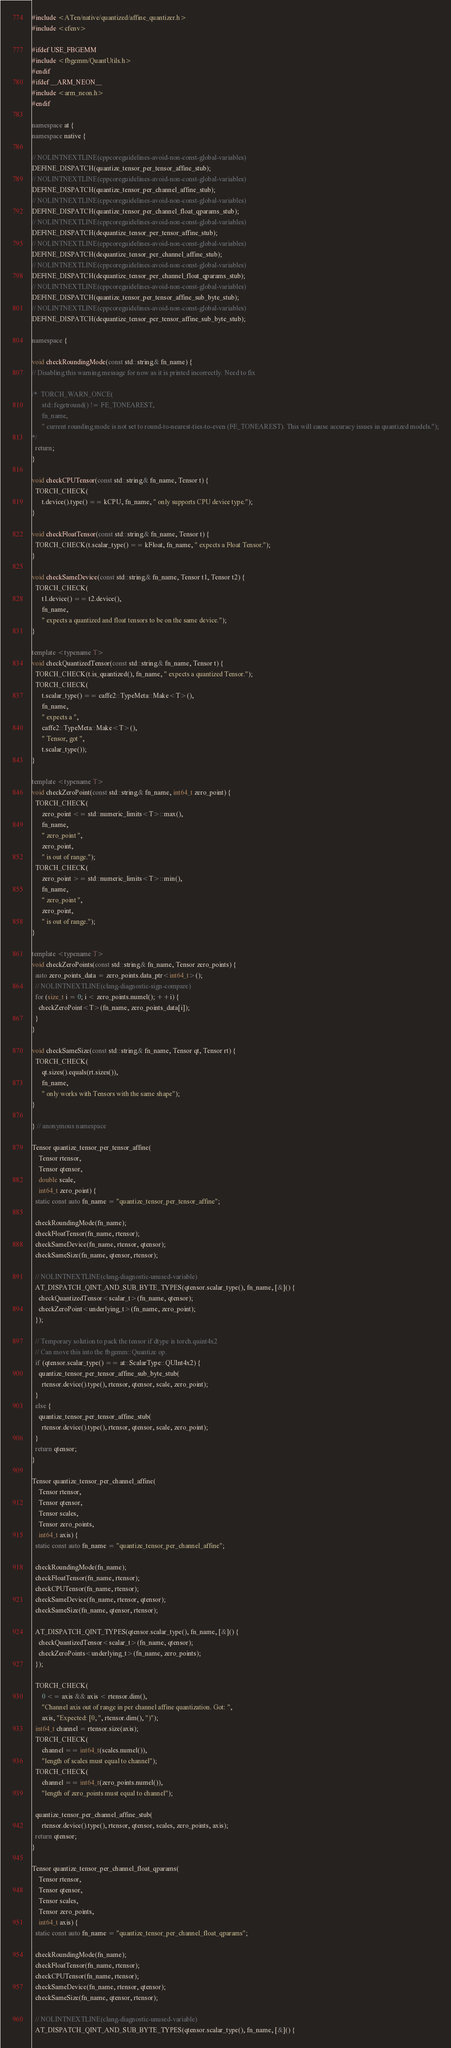<code> <loc_0><loc_0><loc_500><loc_500><_C++_>#include <ATen/native/quantized/affine_quantizer.h>
#include <cfenv>

#ifdef USE_FBGEMM
#include <fbgemm/QuantUtils.h>
#endif
#ifdef __ARM_NEON__
#include <arm_neon.h>
#endif

namespace at {
namespace native {

// NOLINTNEXTLINE(cppcoreguidelines-avoid-non-const-global-variables)
DEFINE_DISPATCH(quantize_tensor_per_tensor_affine_stub);
// NOLINTNEXTLINE(cppcoreguidelines-avoid-non-const-global-variables)
DEFINE_DISPATCH(quantize_tensor_per_channel_affine_stub);
// NOLINTNEXTLINE(cppcoreguidelines-avoid-non-const-global-variables)
DEFINE_DISPATCH(quantize_tensor_per_channel_float_qparams_stub);
// NOLINTNEXTLINE(cppcoreguidelines-avoid-non-const-global-variables)
DEFINE_DISPATCH(dequantize_tensor_per_tensor_affine_stub);
// NOLINTNEXTLINE(cppcoreguidelines-avoid-non-const-global-variables)
DEFINE_DISPATCH(dequantize_tensor_per_channel_affine_stub);
// NOLINTNEXTLINE(cppcoreguidelines-avoid-non-const-global-variables)
DEFINE_DISPATCH(dequantize_tensor_per_channel_float_qparams_stub);
// NOLINTNEXTLINE(cppcoreguidelines-avoid-non-const-global-variables)
DEFINE_DISPATCH(quantize_tensor_per_tensor_affine_sub_byte_stub);
// NOLINTNEXTLINE(cppcoreguidelines-avoid-non-const-global-variables)
DEFINE_DISPATCH(dequantize_tensor_per_tensor_affine_sub_byte_stub);

namespace {

void checkRoundingMode(const std::string& fn_name) {
// Disabling this warning message for now as it is printed incorrectly. Need to fix

/*  TORCH_WARN_ONCE(
      std::fegetround() != FE_TONEAREST,
      fn_name,
      " current rounding mode is not set to round-to-nearest-ties-to-even (FE_TONEAREST). This will cause accuracy issues in quantized models.");
*/
  return;
}

void checkCPUTensor(const std::string& fn_name, Tensor t) {
  TORCH_CHECK(
      t.device().type() == kCPU, fn_name, " only supports CPU device type.");
}

void checkFloatTensor(const std::string& fn_name, Tensor t) {
  TORCH_CHECK(t.scalar_type() == kFloat, fn_name, " expects a Float Tensor.");
}

void checkSameDevice(const std::string& fn_name, Tensor t1, Tensor t2) {
  TORCH_CHECK(
      t1.device() == t2.device(),
      fn_name,
      " expects a quantized and float tensors to be on the same device.");
}

template <typename T>
void checkQuantizedTensor(const std::string& fn_name, Tensor t) {
  TORCH_CHECK(t.is_quantized(), fn_name, " expects a quantized Tensor.");
  TORCH_CHECK(
      t.scalar_type() == caffe2::TypeMeta::Make<T>(),
      fn_name,
      " expects a ",
      caffe2::TypeMeta::Make<T>(),
      " Tensor, got ",
      t.scalar_type());
}

template <typename T>
void checkZeroPoint(const std::string& fn_name, int64_t zero_point) {
  TORCH_CHECK(
      zero_point <= std::numeric_limits<T>::max(),
      fn_name,
      " zero_point ",
      zero_point,
      " is out of range.");
  TORCH_CHECK(
      zero_point >= std::numeric_limits<T>::min(),
      fn_name,
      " zero_point ",
      zero_point,
      " is out of range.");
}

template <typename T>
void checkZeroPoints(const std::string& fn_name, Tensor zero_points) {
  auto zero_points_data = zero_points.data_ptr<int64_t>();
  // NOLINTNEXTLINE(clang-diagnostic-sign-compare)
  for (size_t i = 0; i < zero_points.numel(); ++i) {
    checkZeroPoint<T>(fn_name, zero_points_data[i]);
  }
}

void checkSameSize(const std::string& fn_name, Tensor qt, Tensor rt) {
  TORCH_CHECK(
      qt.sizes().equals(rt.sizes()),
      fn_name,
      " only works with Tensors with the same shape");
}

} // anonymous namespace

Tensor quantize_tensor_per_tensor_affine(
    Tensor rtensor,
    Tensor qtensor,
    double scale,
    int64_t zero_point) {
  static const auto fn_name = "quantize_tensor_per_tensor_affine";

  checkRoundingMode(fn_name);
  checkFloatTensor(fn_name, rtensor);
  checkSameDevice(fn_name, rtensor, qtensor);
  checkSameSize(fn_name, qtensor, rtensor);

  // NOLINTNEXTLINE(clang-diagnostic-unused-variable)
  AT_DISPATCH_QINT_AND_SUB_BYTE_TYPES(qtensor.scalar_type(), fn_name, [&]() {
    checkQuantizedTensor<scalar_t>(fn_name, qtensor);
    checkZeroPoint<underlying_t>(fn_name, zero_point);
  });

  // Temporary solution to pack the tensor if dtype is torch.quint4x2
  // Can move this into the fbgemm::Quantize op.
  if (qtensor.scalar_type() == at::ScalarType::QUInt4x2) {
    quantize_tensor_per_tensor_affine_sub_byte_stub(
      rtensor.device().type(), rtensor, qtensor, scale, zero_point);
  }
  else {
    quantize_tensor_per_tensor_affine_stub(
      rtensor.device().type(), rtensor, qtensor, scale, zero_point);
  }
  return qtensor;
}

Tensor quantize_tensor_per_channel_affine(
    Tensor rtensor,
    Tensor qtensor,
    Tensor scales,
    Tensor zero_points,
    int64_t axis) {
  static const auto fn_name = "quantize_tensor_per_channel_affine";

  checkRoundingMode(fn_name);
  checkFloatTensor(fn_name, rtensor);
  checkCPUTensor(fn_name, rtensor);
  checkSameDevice(fn_name, rtensor, qtensor);
  checkSameSize(fn_name, qtensor, rtensor);

  AT_DISPATCH_QINT_TYPES(qtensor.scalar_type(), fn_name, [&]() {
    checkQuantizedTensor<scalar_t>(fn_name, qtensor);
    checkZeroPoints<underlying_t>(fn_name, zero_points);
  });

  TORCH_CHECK(
      0 <= axis && axis < rtensor.dim(),
      "Channel axis out of range in per channel affine quantization. Got: ",
      axis, "Expected: [0, ", rtensor.dim(), ")");
  int64_t channel = rtensor.size(axis);
  TORCH_CHECK(
      channel == int64_t(scales.numel()),
      "length of scales must equal to channel");
  TORCH_CHECK(
      channel == int64_t(zero_points.numel()),
      "length of zero_points must equal to channel");

  quantize_tensor_per_channel_affine_stub(
      rtensor.device().type(), rtensor, qtensor, scales, zero_points, axis);
  return qtensor;
}

Tensor quantize_tensor_per_channel_float_qparams(
    Tensor rtensor,
    Tensor qtensor,
    Tensor scales,
    Tensor zero_points,
    int64_t axis) {
  static const auto fn_name = "quantize_tensor_per_channel_float_qparams";

  checkRoundingMode(fn_name);
  checkFloatTensor(fn_name, rtensor);
  checkCPUTensor(fn_name, rtensor);
  checkSameDevice(fn_name, rtensor, qtensor);
  checkSameSize(fn_name, qtensor, rtensor);

  // NOLINTNEXTLINE(clang-diagnostic-unused-variable)
  AT_DISPATCH_QINT_AND_SUB_BYTE_TYPES(qtensor.scalar_type(), fn_name, [&]() {</code> 